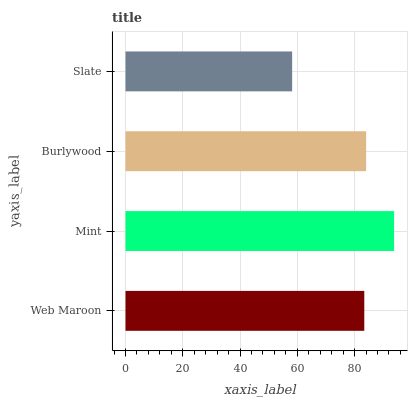Is Slate the minimum?
Answer yes or no. Yes. Is Mint the maximum?
Answer yes or no. Yes. Is Burlywood the minimum?
Answer yes or no. No. Is Burlywood the maximum?
Answer yes or no. No. Is Mint greater than Burlywood?
Answer yes or no. Yes. Is Burlywood less than Mint?
Answer yes or no. Yes. Is Burlywood greater than Mint?
Answer yes or no. No. Is Mint less than Burlywood?
Answer yes or no. No. Is Burlywood the high median?
Answer yes or no. Yes. Is Web Maroon the low median?
Answer yes or no. Yes. Is Web Maroon the high median?
Answer yes or no. No. Is Mint the low median?
Answer yes or no. No. 